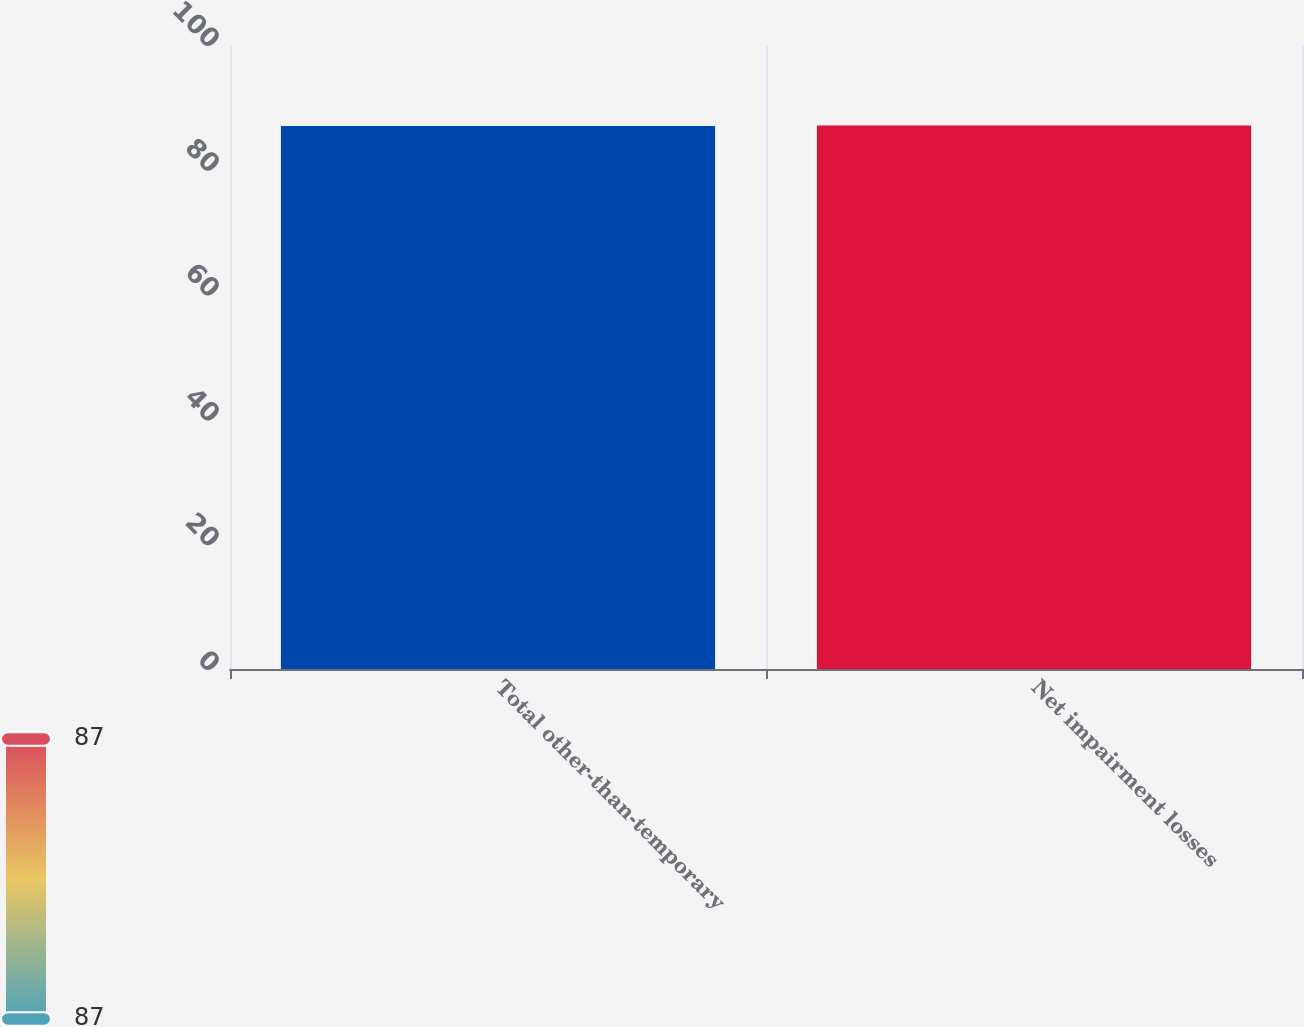<chart> <loc_0><loc_0><loc_500><loc_500><bar_chart><fcel>Total other-than-temporary<fcel>Net impairment losses<nl><fcel>87<fcel>87.1<nl></chart> 